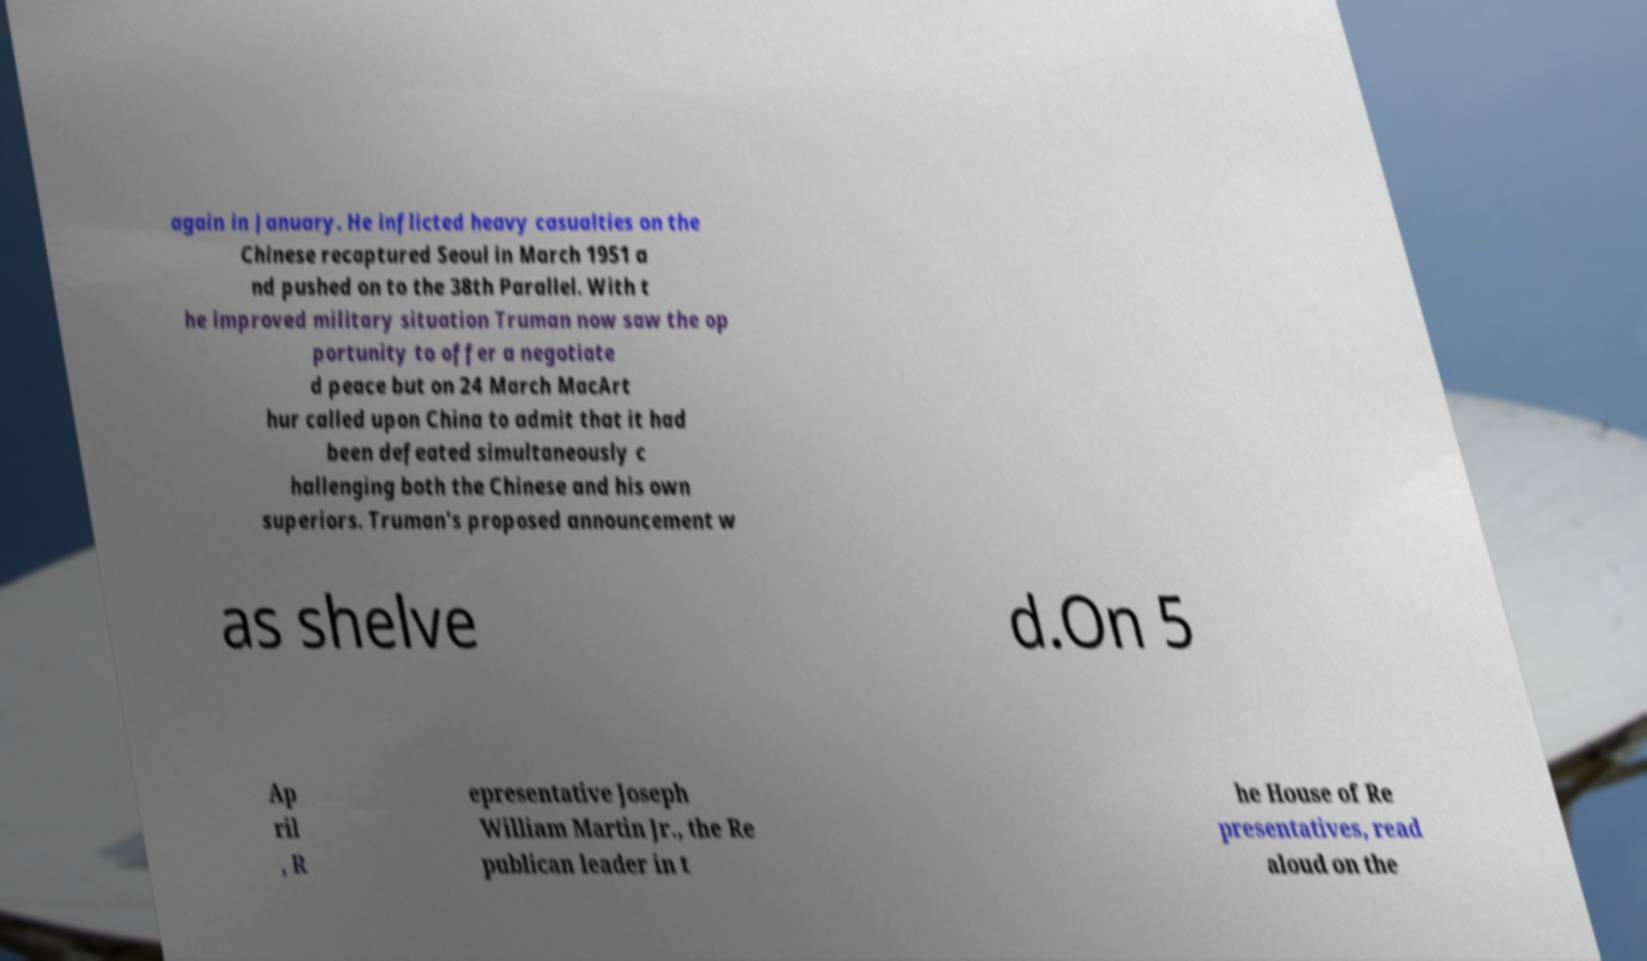Please identify and transcribe the text found in this image. again in January. He inflicted heavy casualties on the Chinese recaptured Seoul in March 1951 a nd pushed on to the 38th Parallel. With t he improved military situation Truman now saw the op portunity to offer a negotiate d peace but on 24 March MacArt hur called upon China to admit that it had been defeated simultaneously c hallenging both the Chinese and his own superiors. Truman's proposed announcement w as shelve d.On 5 Ap ril , R epresentative Joseph William Martin Jr., the Re publican leader in t he House of Re presentatives, read aloud on the 